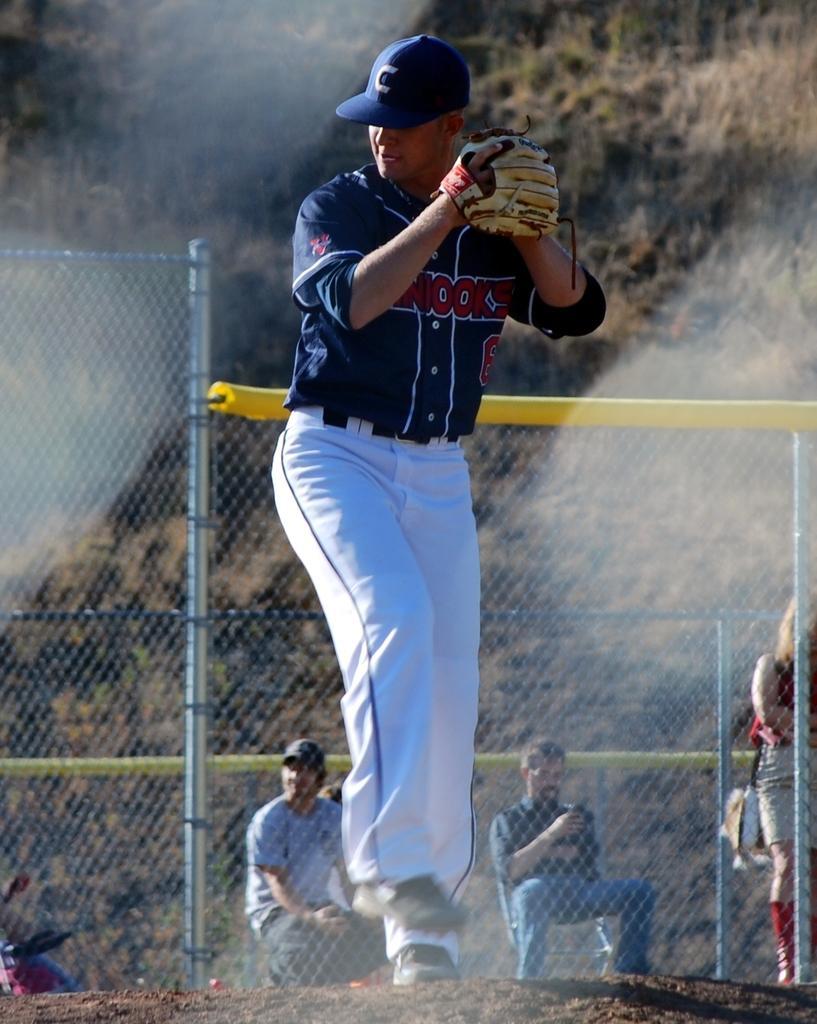In one or two sentences, can you explain what this image depicts? This picture shows a man standing and he wore cap on his head and glove to his hand and we see few people seated on the chairs and a woman standing she wore a bag and we see a metal fence and trees on the back. 